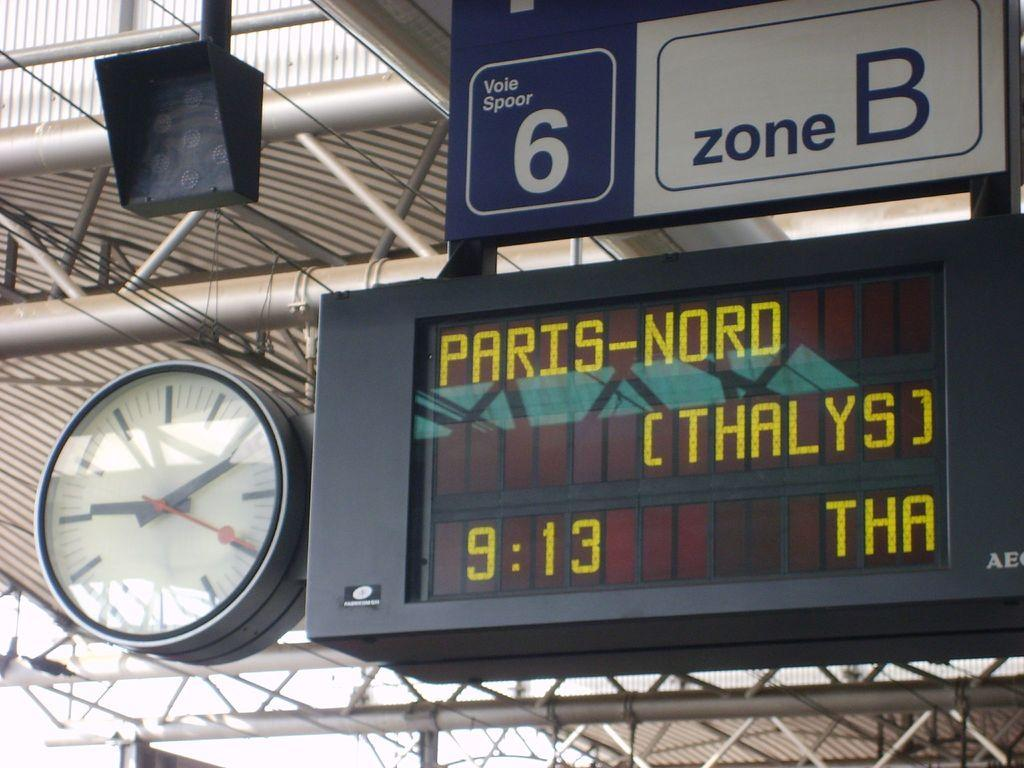<image>
Write a terse but informative summary of the picture. a signage group with Vole spoor 6, Zone B, and Paris-Nord on them. 